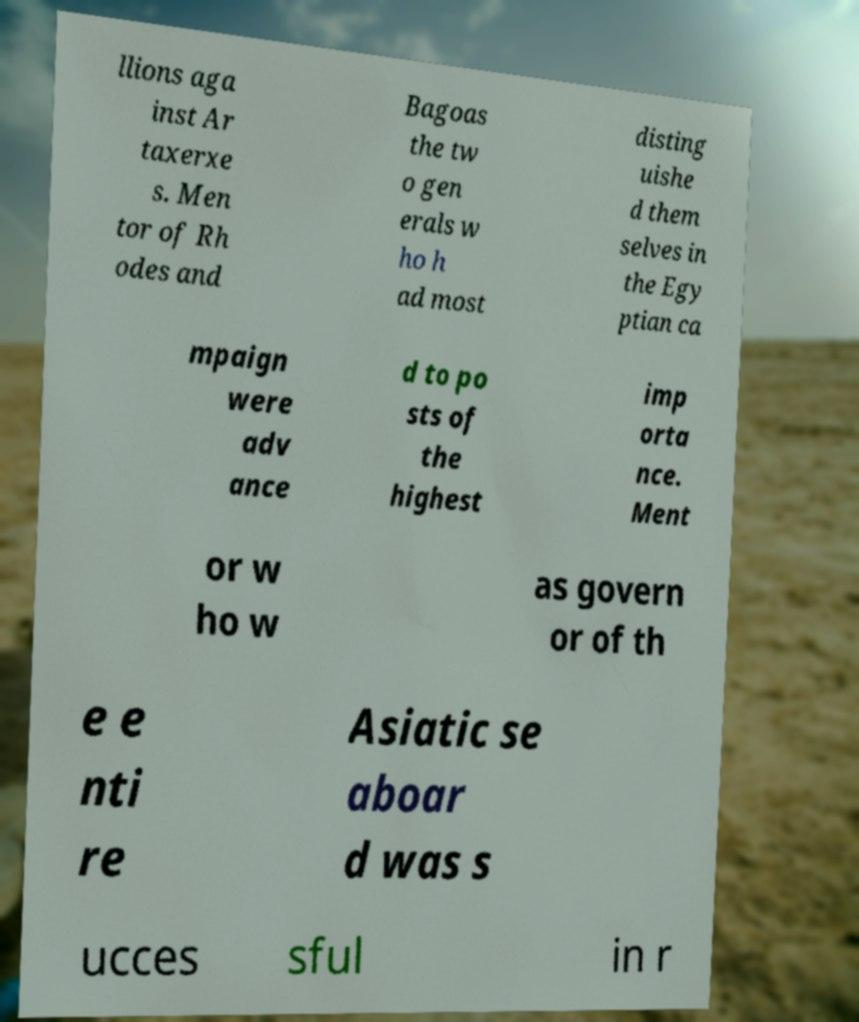Can you read and provide the text displayed in the image?This photo seems to have some interesting text. Can you extract and type it out for me? llions aga inst Ar taxerxe s. Men tor of Rh odes and Bagoas the tw o gen erals w ho h ad most disting uishe d them selves in the Egy ptian ca mpaign were adv ance d to po sts of the highest imp orta nce. Ment or w ho w as govern or of th e e nti re Asiatic se aboar d was s ucces sful in r 